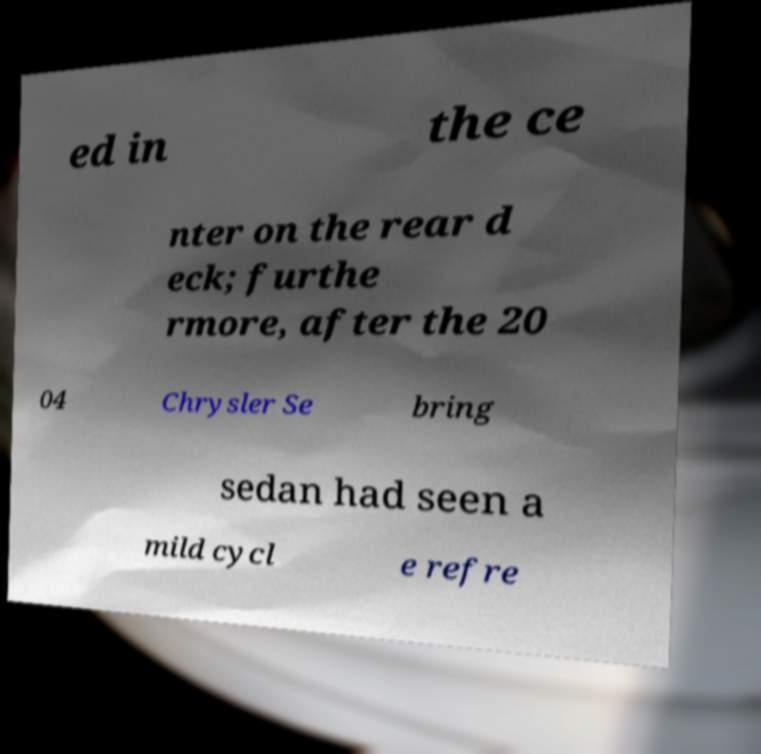Can you accurately transcribe the text from the provided image for me? ed in the ce nter on the rear d eck; furthe rmore, after the 20 04 Chrysler Se bring sedan had seen a mild cycl e refre 